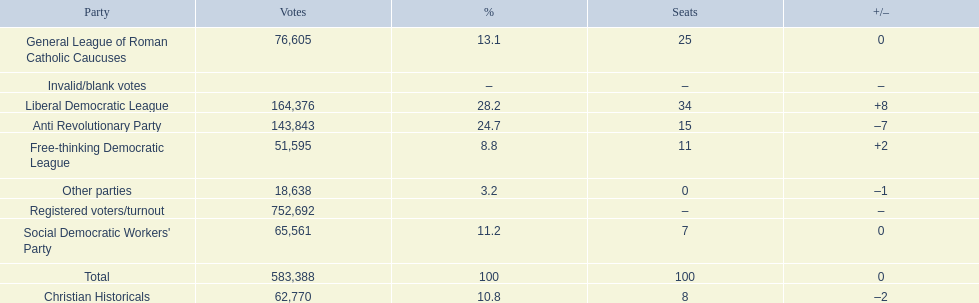Name the top three parties? Liberal Democratic League, Anti Revolutionary Party, General League of Roman Catholic Caucuses. 